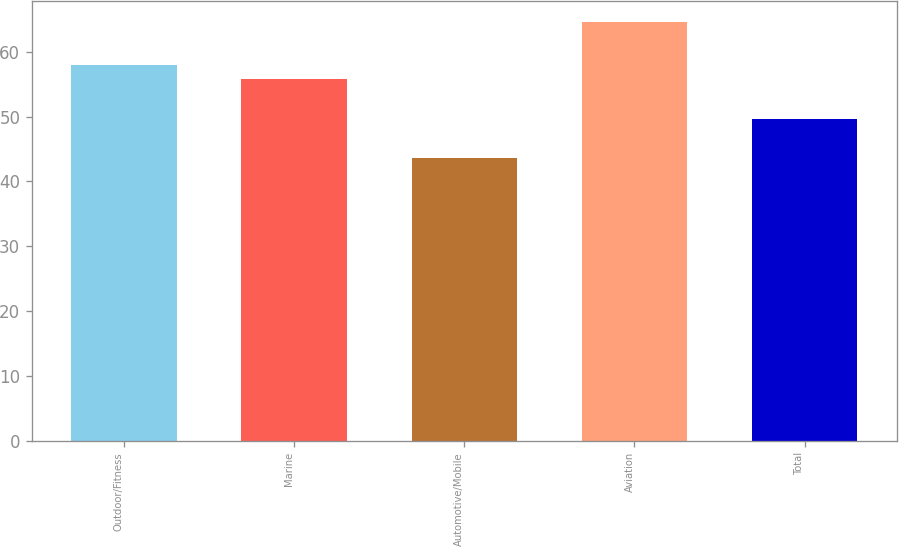<chart> <loc_0><loc_0><loc_500><loc_500><bar_chart><fcel>Outdoor/Fitness<fcel>Marine<fcel>Automotive/Mobile<fcel>Aviation<fcel>Total<nl><fcel>57.91<fcel>55.8<fcel>43.6<fcel>64.7<fcel>49.7<nl></chart> 